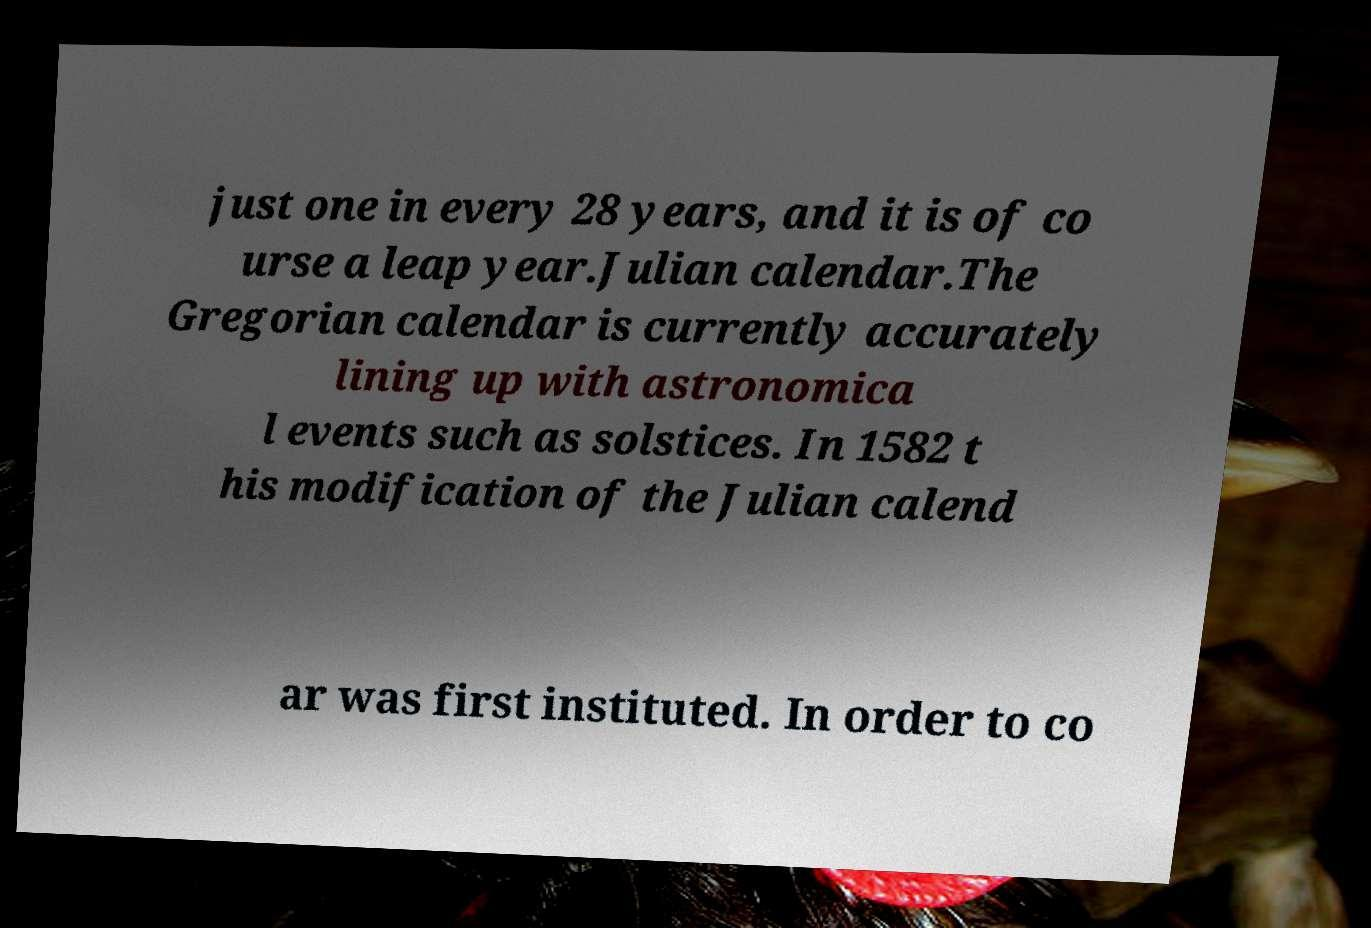Please read and relay the text visible in this image. What does it say? just one in every 28 years, and it is of co urse a leap year.Julian calendar.The Gregorian calendar is currently accurately lining up with astronomica l events such as solstices. In 1582 t his modification of the Julian calend ar was first instituted. In order to co 